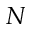Convert formula to latex. <formula><loc_0><loc_0><loc_500><loc_500>N</formula> 